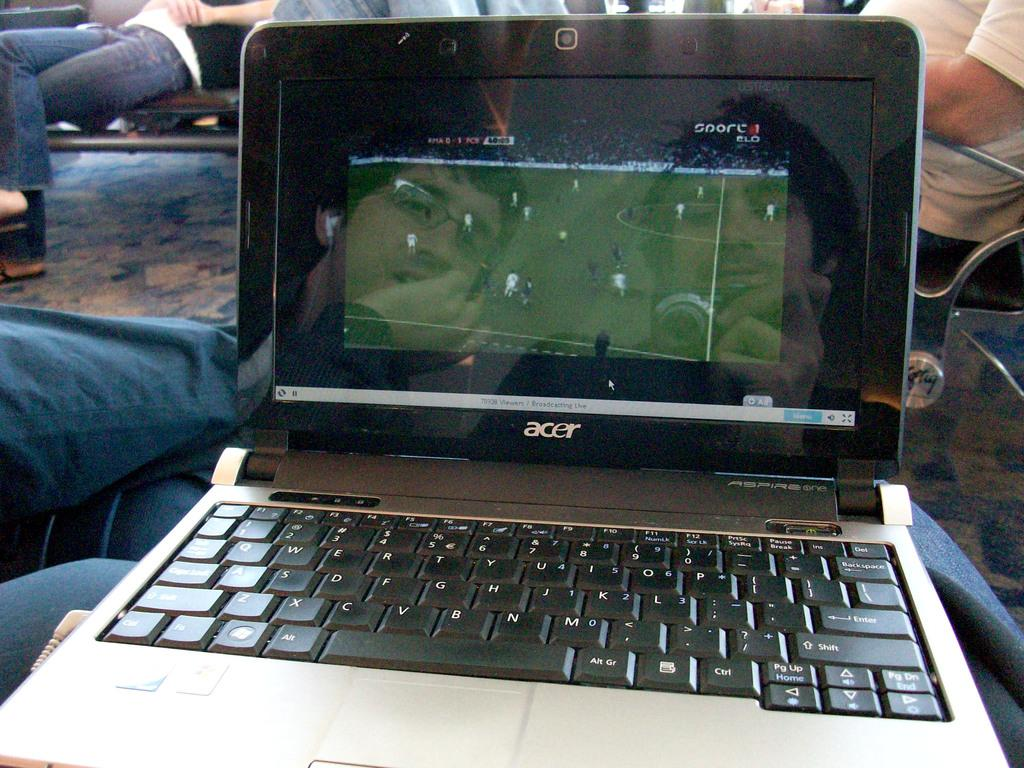<image>
Relay a brief, clear account of the picture shown. an ACER lap top computer open to a soccer game 